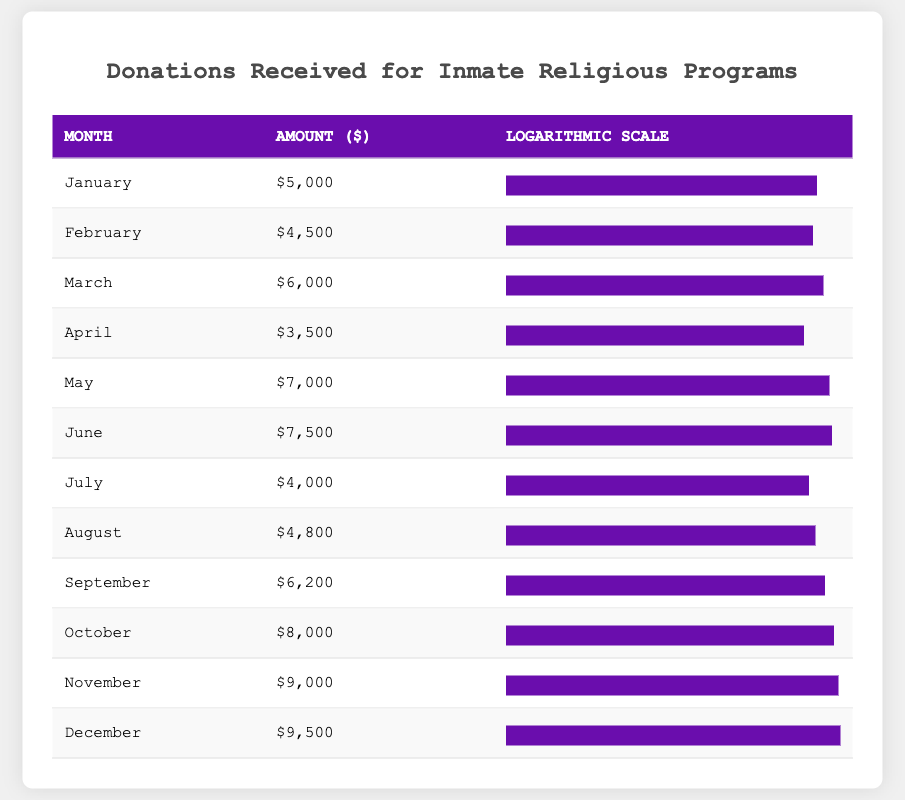What was the highest donation received in a month? The highest donation can be found by looking at the "Amount ($)" column and identifying the maximum value. From the table, the highest amount is 9500 for December.
Answer: 9500 In which month was the lowest donation recorded? To find the lowest donation, we examine the "Amount ($)" column and locate the minimum value. The lowest amount is 3500 for April.
Answer: April What is the total amount of donations received from January to March? We need to sum the donations from January, February, and March: 5000 + 4500 + 6000 = 15500.
Answer: 15500 Is the amount received in October greater than the average of donations for the entire year? First, we calculate the total donations for the year: 5000 + 4500 + 6000 + 3500 + 7000 + 7500 + 4000 + 4800 + 6200 + 8000 + 9000 + 9500 = 71100. Then, we divide by 12 (the number of months), giving an average of 5925. Since October's amount is 8000, which is greater than 5925, the answer is yes.
Answer: Yes What is the median donation amount for the year? To find the median, we list all 12 donations in order: 3500, 4000, 4500, 4800, 5000, 6000, 6200, 7000, 7500, 8000, 9000, 9500. Since there are 12 values, the median is the average of the 6th and 7th numbers. Thus, (6000 + 6200)/2 = 6100.
Answer: 6100 